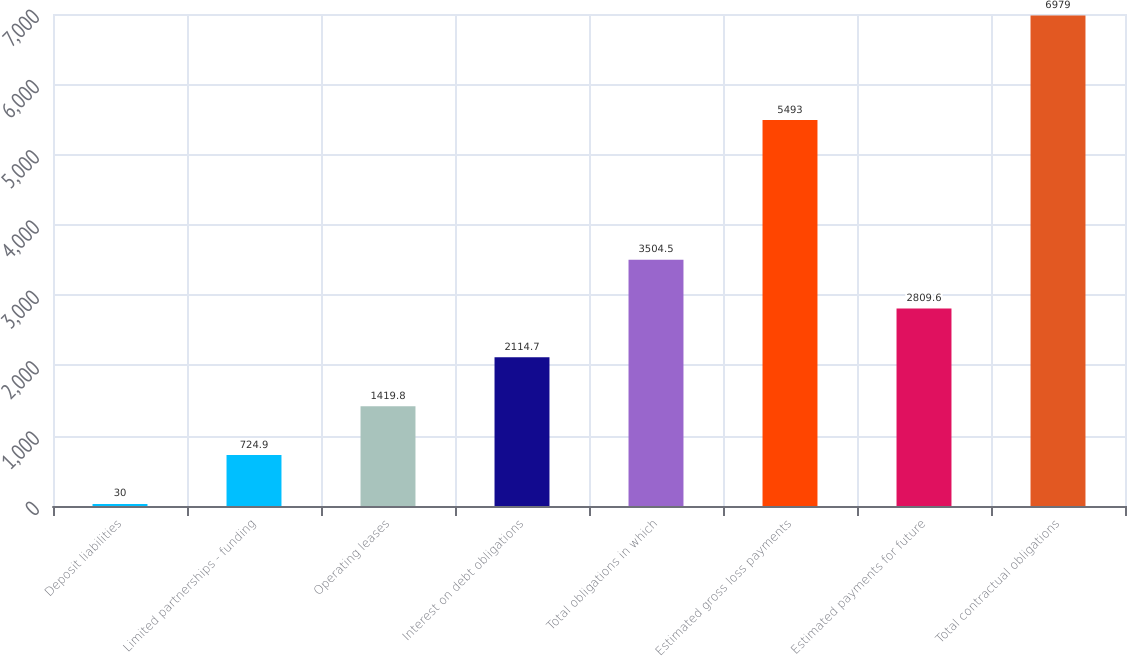Convert chart to OTSL. <chart><loc_0><loc_0><loc_500><loc_500><bar_chart><fcel>Deposit liabilities<fcel>Limited partnerships - funding<fcel>Operating leases<fcel>Interest on debt obligations<fcel>Total obligations in which<fcel>Estimated gross loss payments<fcel>Estimated payments for future<fcel>Total contractual obligations<nl><fcel>30<fcel>724.9<fcel>1419.8<fcel>2114.7<fcel>3504.5<fcel>5493<fcel>2809.6<fcel>6979<nl></chart> 